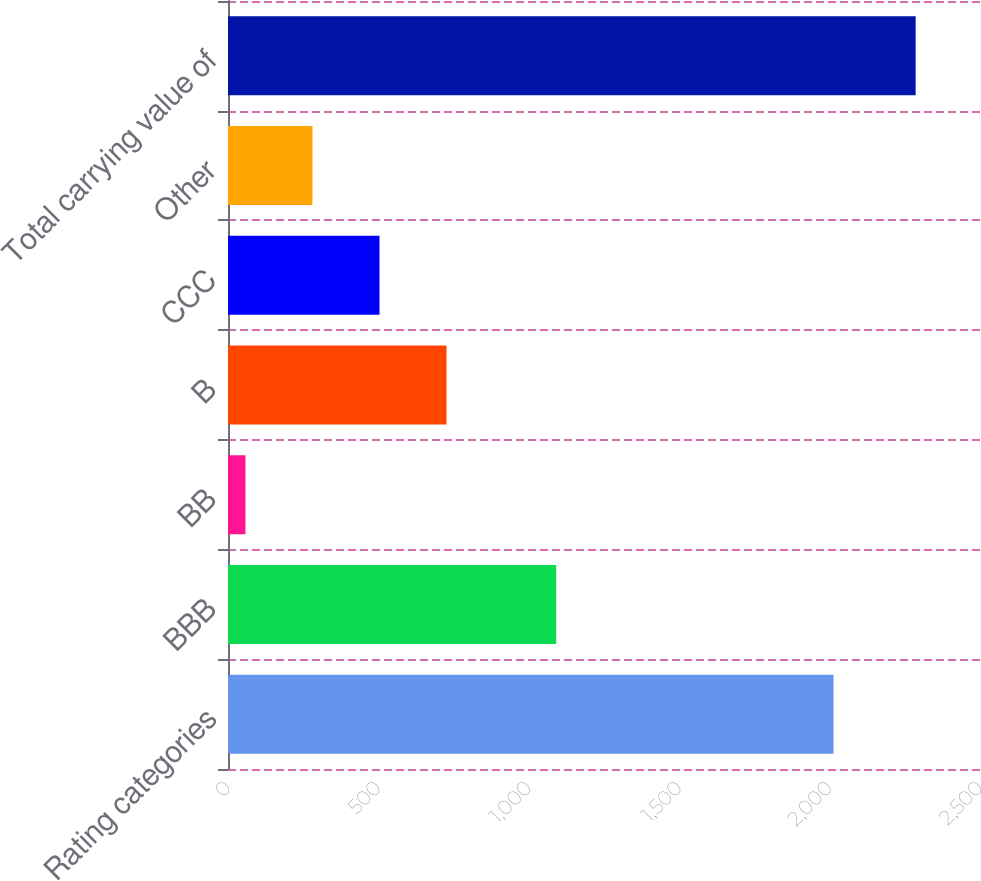Convert chart to OTSL. <chart><loc_0><loc_0><loc_500><loc_500><bar_chart><fcel>Rating categories<fcel>BBB<fcel>BB<fcel>B<fcel>CCC<fcel>Other<fcel>Total carrying value of<nl><fcel>2013<fcel>1091<fcel>58<fcel>726.4<fcel>503.6<fcel>280.8<fcel>2286<nl></chart> 